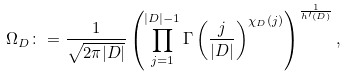Convert formula to latex. <formula><loc_0><loc_0><loc_500><loc_500>\Omega _ { D } \colon = \frac { 1 } { \sqrt { 2 \pi | D | } } \left ( \prod _ { j = 1 } ^ { | D | - 1 } \Gamma \left ( \frac { j } { | D | } \right ) ^ { \chi _ { D } ( j ) } \right ) ^ { \frac { 1 } { h ^ { \prime } ( D ) } } ,</formula> 